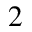Convert formula to latex. <formula><loc_0><loc_0><loc_500><loc_500>_ { 2 }</formula> 